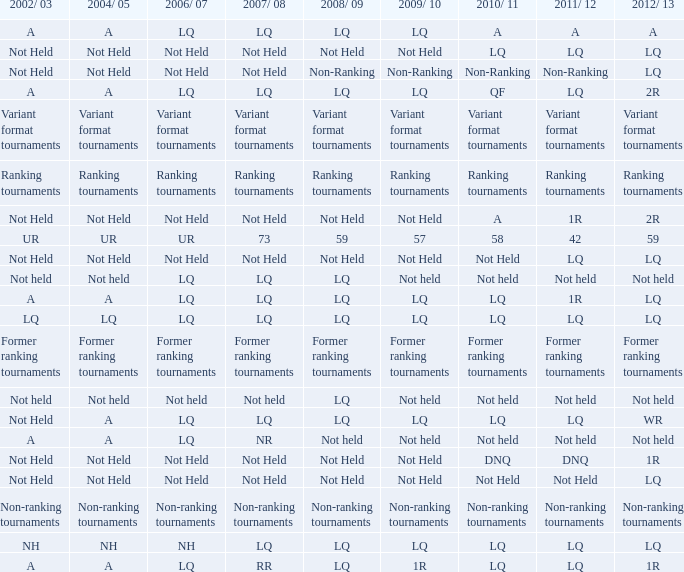Name the 2009/10 with 2011/12 of a LQ. 